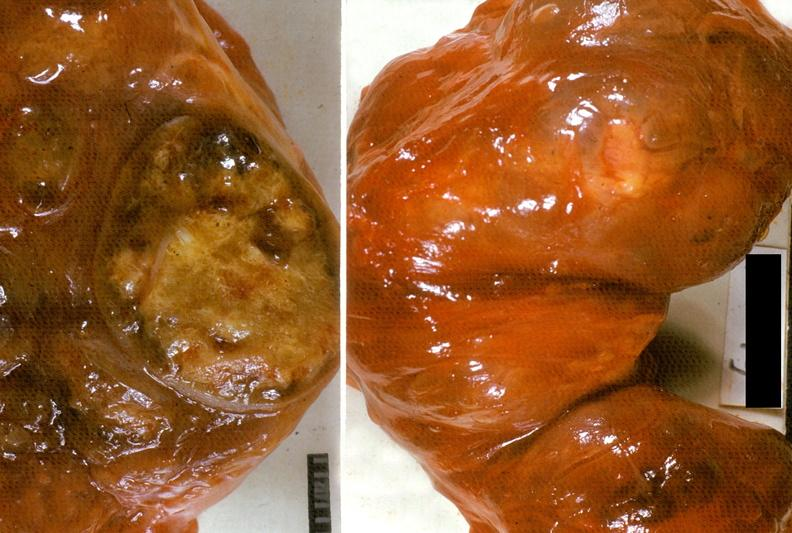does newborn cord around neck show thyroid, nodular goiter?
Answer the question using a single word or phrase. No 